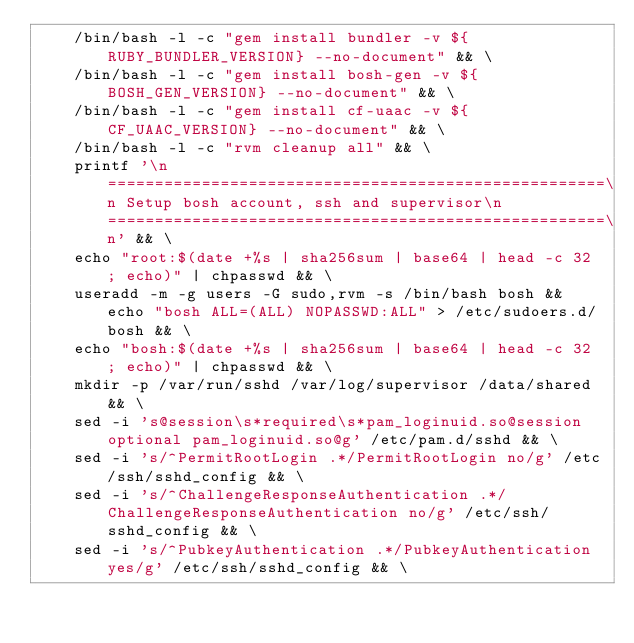Convert code to text. <code><loc_0><loc_0><loc_500><loc_500><_Dockerfile_>    /bin/bash -l -c "gem install bundler -v ${RUBY_BUNDLER_VERSION} --no-document" && \
    /bin/bash -l -c "gem install bosh-gen -v ${BOSH_GEN_VERSION} --no-document" && \
    /bin/bash -l -c "gem install cf-uaac -v ${CF_UAAC_VERSION} --no-document" && \
    /bin/bash -l -c "rvm cleanup all" && \
    printf '\n=====================================================\n Setup bosh account, ssh and supervisor\n=====================================================\n' && \
    echo "root:$(date +%s | sha256sum | base64 | head -c 32 ; echo)" | chpasswd && \
    useradd -m -g users -G sudo,rvm -s /bin/bash bosh && echo "bosh ALL=(ALL) NOPASSWD:ALL" > /etc/sudoers.d/bosh && \
    echo "bosh:$(date +%s | sha256sum | base64 | head -c 32 ; echo)" | chpasswd && \
    mkdir -p /var/run/sshd /var/log/supervisor /data/shared && \
    sed -i 's@session\s*required\s*pam_loginuid.so@session optional pam_loginuid.so@g' /etc/pam.d/sshd && \
    sed -i 's/^PermitRootLogin .*/PermitRootLogin no/g' /etc/ssh/sshd_config && \
    sed -i 's/^ChallengeResponseAuthentication .*/ChallengeResponseAuthentication no/g' /etc/ssh/sshd_config && \
    sed -i 's/^PubkeyAuthentication .*/PubkeyAuthentication yes/g' /etc/ssh/sshd_config && \</code> 